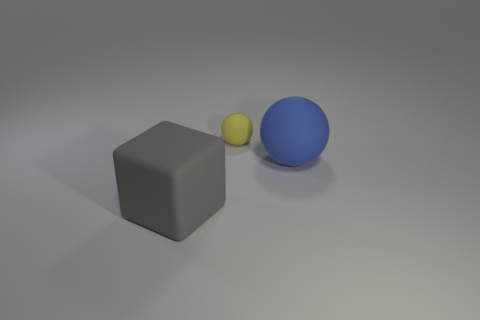What color is the object right of the matte sphere behind the big object on the right side of the big gray matte thing?
Keep it short and to the point. Blue. Is the material of the object that is behind the big blue object the same as the big blue sphere?
Your answer should be compact. Yes. Are there any other small matte objects of the same color as the tiny matte object?
Give a very brief answer. No. Is there a gray rubber object?
Your response must be concise. Yes. There is a object behind the blue ball; is its size the same as the gray block?
Keep it short and to the point. No. Are there fewer large red matte spheres than blue balls?
Provide a succinct answer. Yes. There is a large rubber object behind the big rubber thing that is in front of the big matte thing that is behind the gray block; what shape is it?
Your answer should be compact. Sphere. Is there another tiny yellow thing that has the same material as the yellow thing?
Your answer should be very brief. No. There is a matte ball behind the large blue rubber ball; is it the same color as the big rubber thing to the right of the gray block?
Give a very brief answer. No. Are there fewer rubber balls behind the gray rubber object than big yellow rubber cubes?
Your answer should be very brief. No. 